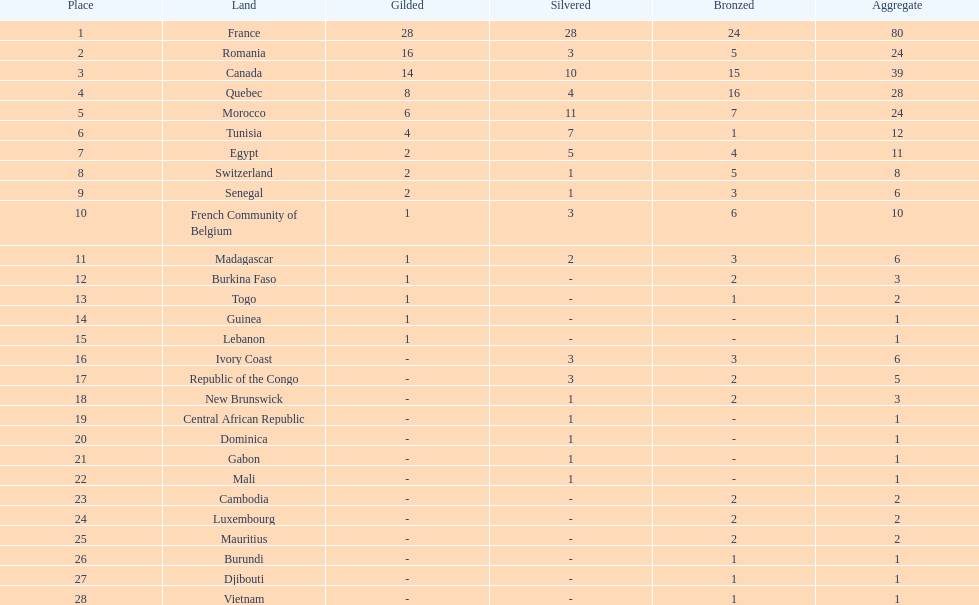In how many counties is there a minimum of one silver medal? 18. 